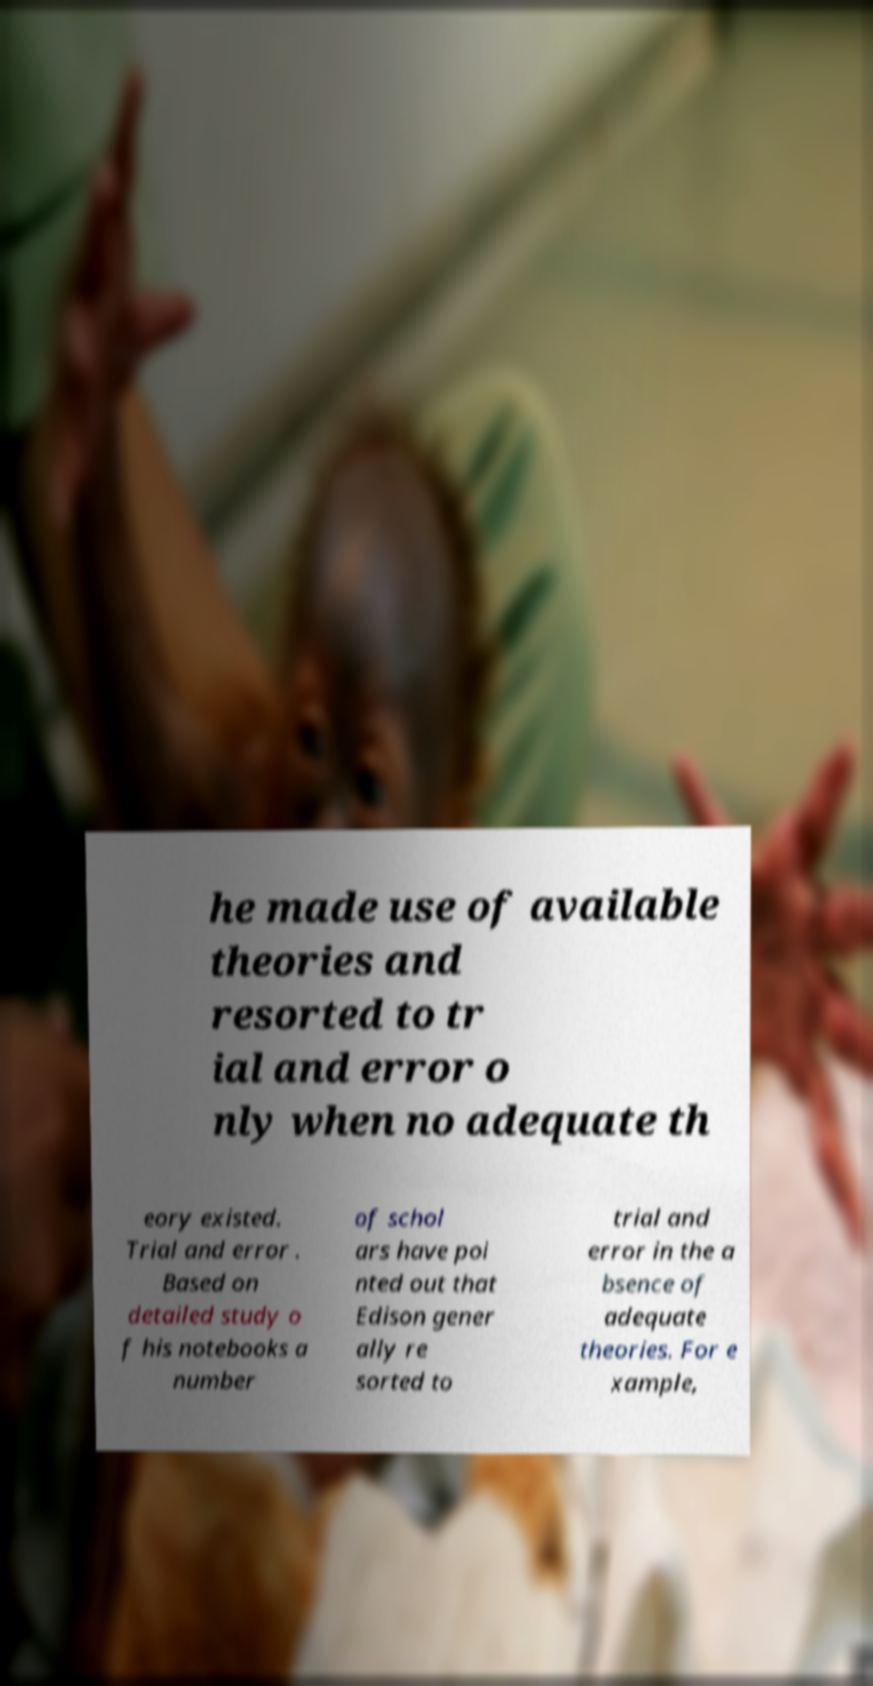Could you assist in decoding the text presented in this image and type it out clearly? he made use of available theories and resorted to tr ial and error o nly when no adequate th eory existed. Trial and error . Based on detailed study o f his notebooks a number of schol ars have poi nted out that Edison gener ally re sorted to trial and error in the a bsence of adequate theories. For e xample, 